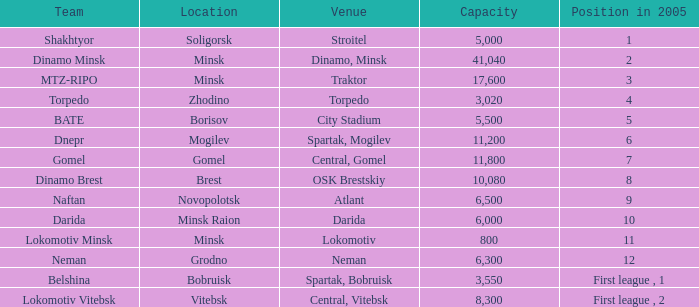Can you tell me the highest Capacity that has the Team of torpedo? 3020.0. 